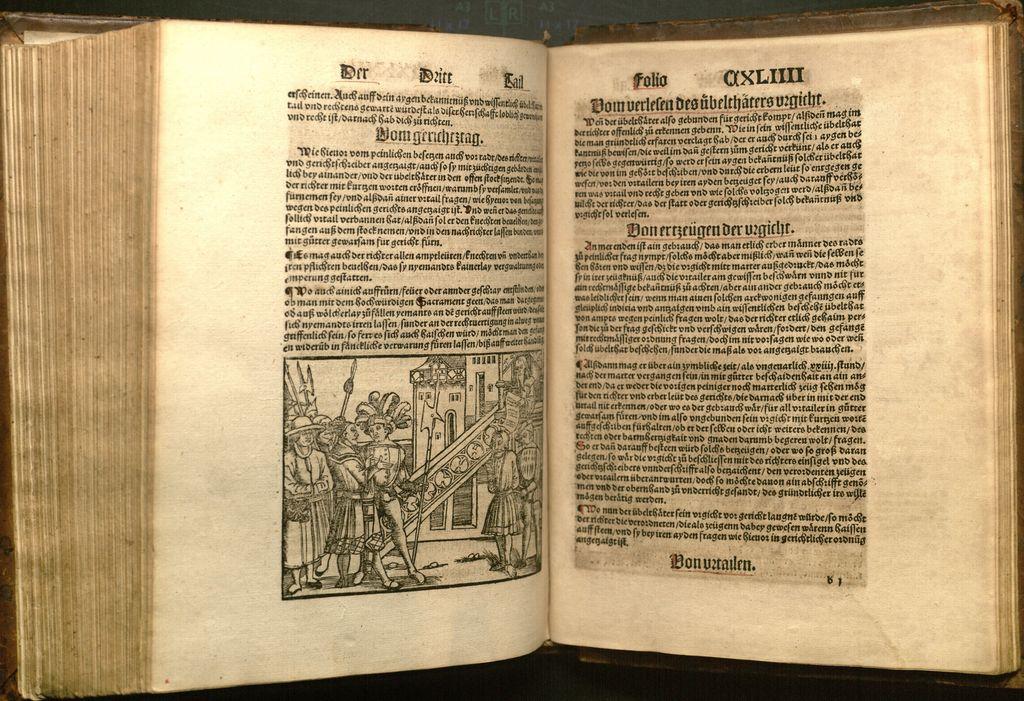Is that book in a foreign language?
Provide a short and direct response. Yes. 